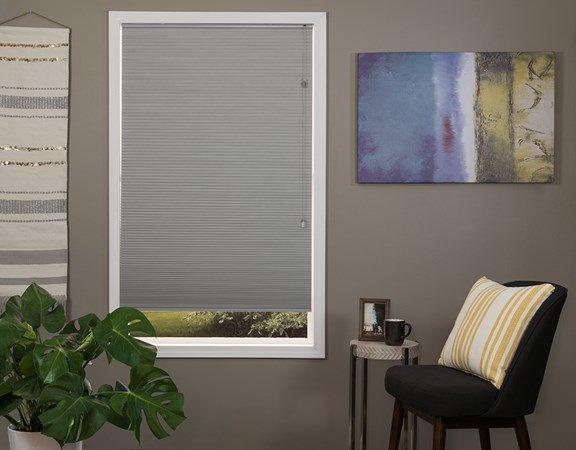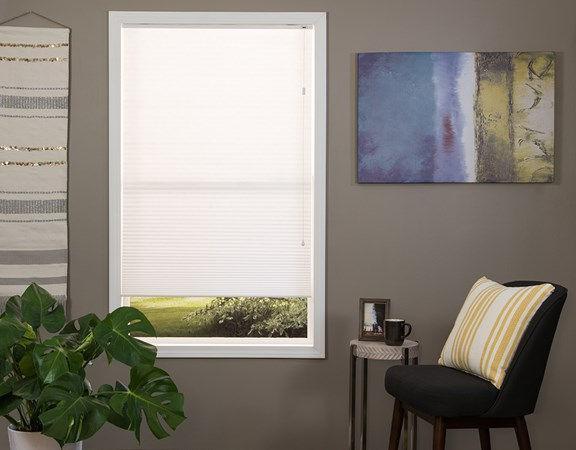The first image is the image on the left, the second image is the image on the right. Assess this claim about the two images: "There is exactly one window in the right image.". Correct or not? Answer yes or no. Yes. The first image is the image on the left, the second image is the image on the right. Examine the images to the left and right. Is the description "There is a total of two blinds." accurate? Answer yes or no. Yes. 